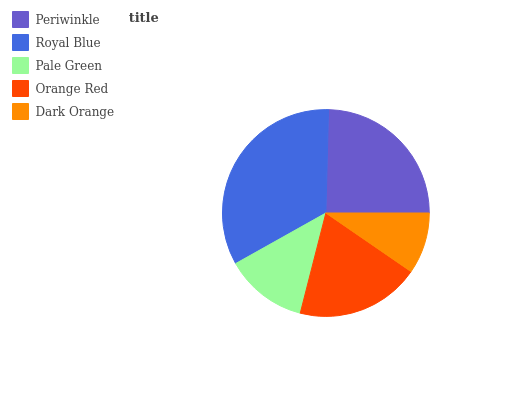Is Dark Orange the minimum?
Answer yes or no. Yes. Is Royal Blue the maximum?
Answer yes or no. Yes. Is Pale Green the minimum?
Answer yes or no. No. Is Pale Green the maximum?
Answer yes or no. No. Is Royal Blue greater than Pale Green?
Answer yes or no. Yes. Is Pale Green less than Royal Blue?
Answer yes or no. Yes. Is Pale Green greater than Royal Blue?
Answer yes or no. No. Is Royal Blue less than Pale Green?
Answer yes or no. No. Is Orange Red the high median?
Answer yes or no. Yes. Is Orange Red the low median?
Answer yes or no. Yes. Is Periwinkle the high median?
Answer yes or no. No. Is Royal Blue the low median?
Answer yes or no. No. 